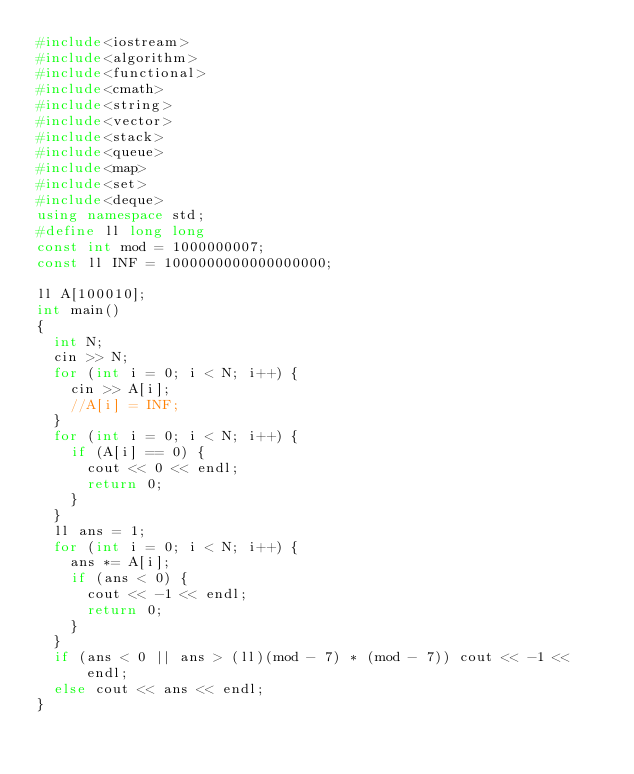<code> <loc_0><loc_0><loc_500><loc_500><_C++_>#include<iostream>
#include<algorithm>
#include<functional>
#include<cmath>
#include<string>
#include<vector>
#include<stack>
#include<queue>
#include<map>
#include<set>
#include<deque>
using namespace std;
#define ll long long
const int mod = 1000000007;
const ll INF = 1000000000000000000;

ll A[100010];
int main()
{
	int N;
	cin >> N;
	for (int i = 0; i < N; i++) {
		cin >> A[i];
		//A[i] = INF;
	}
	for (int i = 0; i < N; i++) {
		if (A[i] == 0) {
			cout << 0 << endl;
			return 0;
		}
	}
	ll ans = 1;
	for (int i = 0; i < N; i++) {
		ans *= A[i];
		if (ans < 0) {
			cout << -1 << endl;
			return 0;
		}
	}
	if (ans < 0 || ans > (ll)(mod - 7) * (mod - 7)) cout << -1 << endl;
	else cout << ans << endl;
}
</code> 